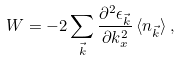<formula> <loc_0><loc_0><loc_500><loc_500>W = - 2 \sum _ { \vec { k } } \frac { \partial ^ { 2 } \epsilon _ { \vec { k } } } { \partial k _ { x } ^ { 2 } } \, \langle n _ { \vec { k } } \rangle \, ,</formula> 